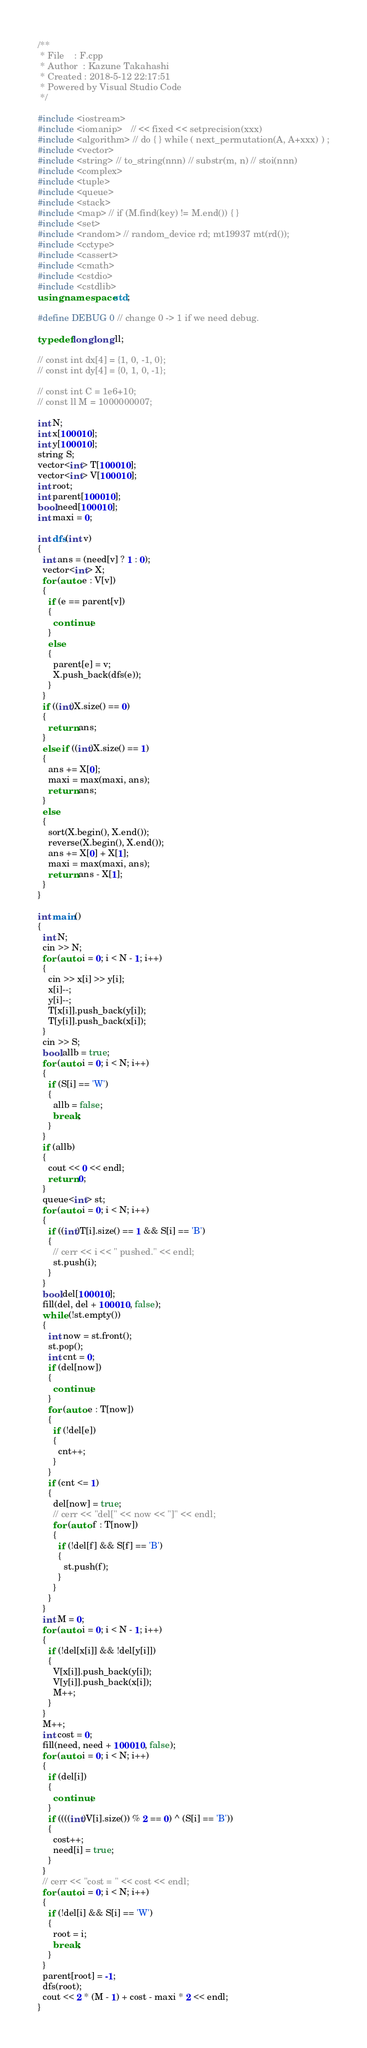Convert code to text. <code><loc_0><loc_0><loc_500><loc_500><_C++_>/**
 * File    : F.cpp
 * Author  : Kazune Takahashi
 * Created : 2018-5-12 22:17:51
 * Powered by Visual Studio Code
 */

#include <iostream>
#include <iomanip>   // << fixed << setprecision(xxx)
#include <algorithm> // do { } while ( next_permutation(A, A+xxx) ) ;
#include <vector>
#include <string> // to_string(nnn) // substr(m, n) // stoi(nnn)
#include <complex>
#include <tuple>
#include <queue>
#include <stack>
#include <map> // if (M.find(key) != M.end()) { }
#include <set>
#include <random> // random_device rd; mt19937 mt(rd());
#include <cctype>
#include <cassert>
#include <cmath>
#include <cstdio>
#include <cstdlib>
using namespace std;

#define DEBUG 0 // change 0 -> 1 if we need debug.

typedef long long ll;

// const int dx[4] = {1, 0, -1, 0};
// const int dy[4] = {0, 1, 0, -1};

// const int C = 1e6+10;
// const ll M = 1000000007;

int N;
int x[100010];
int y[100010];
string S;
vector<int> T[100010];
vector<int> V[100010];
int root;
int parent[100010];
bool need[100010];
int maxi = 0;

int dfs(int v)
{
  int ans = (need[v] ? 1 : 0);
  vector<int> X;
  for (auto e : V[v])
  {
    if (e == parent[v])
    {
      continue;
    }
    else
    {
      parent[e] = v;
      X.push_back(dfs(e));
    }
  }
  if ((int)X.size() == 0)
  {
    return ans;
  }
  else if ((int)X.size() == 1)
  {
    ans += X[0];
    maxi = max(maxi, ans);
    return ans;
  }
  else
  {
    sort(X.begin(), X.end());
    reverse(X.begin(), X.end());
    ans += X[0] + X[1];
    maxi = max(maxi, ans);
    return ans - X[1];
  }
}

int main()
{
  int N;
  cin >> N;
  for (auto i = 0; i < N - 1; i++)
  {
    cin >> x[i] >> y[i];
    x[i]--;
    y[i]--;
    T[x[i]].push_back(y[i]);
    T[y[i]].push_back(x[i]);
  }
  cin >> S;
  bool allb = true;
  for (auto i = 0; i < N; i++)
  {
    if (S[i] == 'W')
    {
      allb = false;
      break;
    }
  }
  if (allb)
  {
    cout << 0 << endl;
    return 0;
  }
  queue<int> st;
  for (auto i = 0; i < N; i++)
  {
    if ((int)T[i].size() == 1 && S[i] == 'B')
    {
      // cerr << i << " pushed." << endl;
      st.push(i);
    }
  }
  bool del[100010];
  fill(del, del + 100010, false);
  while (!st.empty())
  {
    int now = st.front();
    st.pop();
    int cnt = 0;
    if (del[now])
    {
      continue;
    }
    for (auto e : T[now])
    {
      if (!del[e])
      {
        cnt++;
      }
    }
    if (cnt <= 1)
    {
      del[now] = true;
      // cerr << "del[" << now << "]" << endl;
      for (auto f : T[now])
      {
        if (!del[f] && S[f] == 'B')
        {
          st.push(f);
        }
      }
    }
  }
  int M = 0;
  for (auto i = 0; i < N - 1; i++)
  {
    if (!del[x[i]] && !del[y[i]])
    {
      V[x[i]].push_back(y[i]);
      V[y[i]].push_back(x[i]);
      M++;
    }
  }
  M++;
  int cost = 0;
  fill(need, need + 100010, false);
  for (auto i = 0; i < N; i++)
  {
    if (del[i])
    {
      continue;
    }
    if ((((int)V[i].size()) % 2 == 0) ^ (S[i] == 'B'))
    {
      cost++;
      need[i] = true;
    }
  }
  // cerr << "cost = " << cost << endl;
  for (auto i = 0; i < N; i++)
  {
    if (!del[i] && S[i] == 'W')
    {
      root = i;
      break;
    }
  }
  parent[root] = -1;
  dfs(root);
  cout << 2 * (M - 1) + cost - maxi * 2 << endl;
}</code> 